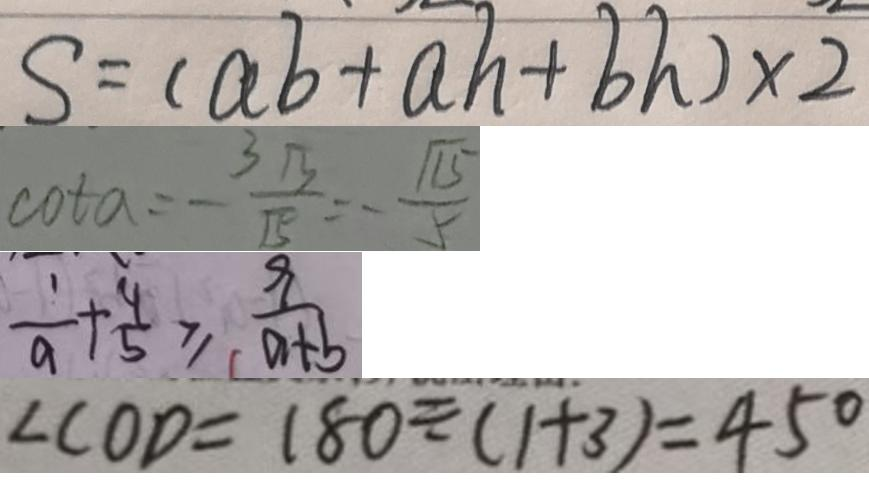<formula> <loc_0><loc_0><loc_500><loc_500>S = ( a b + a h + b h ) \times 2 
 \cot \alpha = - \frac { 3 \sqrt { 3 } } { \sqrt { 5 } } = - \frac { \sqrt { 1 5 } } { 5 } 
 \frac { 1 } { a } + \frac { 4 } { 5 } \geq \frac { 9 } { a + b } 
 \angle C O D = 1 8 0 \div ( 1 + 3 ) = 4 5 ^ { \circ }</formula> 